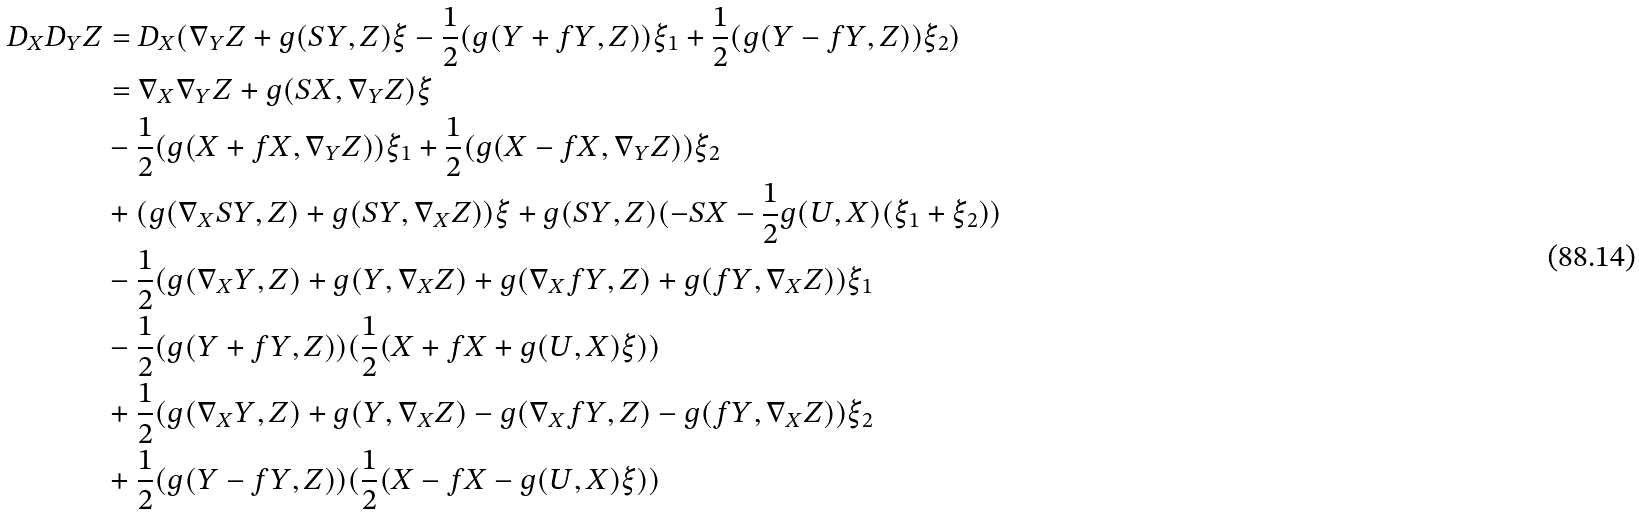Convert formula to latex. <formula><loc_0><loc_0><loc_500><loc_500>D _ { X } D _ { Y } Z & = D _ { X } ( \nabla _ { Y } Z + g ( S Y , Z ) \xi - \frac { 1 } { 2 } ( g ( Y + f Y , Z ) ) \xi _ { 1 } + \frac { 1 } { 2 } ( g ( Y - f Y , Z ) ) \xi _ { 2 } ) \\ & = \nabla _ { X } \nabla _ { Y } Z + g ( S X , \nabla _ { Y } Z ) \xi \\ & - \frac { 1 } { 2 } ( g ( X + f X , \nabla _ { Y } Z ) ) \xi _ { 1 } + \frac { 1 } { 2 } ( g ( X - f X , \nabla _ { Y } Z ) ) \xi _ { 2 } \\ & + ( g ( \nabla _ { X } S Y , Z ) + g ( S Y , \nabla _ { X } Z ) ) \xi + g ( S Y , Z ) ( - S X - \frac { 1 } { 2 } g ( U , X ) ( \xi _ { 1 } + \xi _ { 2 } ) ) \\ & - \frac { 1 } { 2 } ( g ( \nabla _ { X } Y , Z ) + g ( Y , \nabla _ { X } Z ) + g ( \nabla _ { X } f Y , Z ) + g ( f Y , \nabla _ { X } Z ) ) \xi _ { 1 } \\ & - \frac { 1 } { 2 } ( g ( Y + f Y , Z ) ) ( \frac { 1 } { 2 } ( X + f X + g ( U , X ) \xi ) ) \\ & + \frac { 1 } { 2 } ( g ( \nabla _ { X } Y , Z ) + g ( Y , \nabla _ { X } Z ) - g ( \nabla _ { X } f Y , Z ) - g ( f Y , \nabla _ { X } Z ) ) \xi _ { 2 } \\ & + \frac { 1 } { 2 } ( g ( Y - f Y , Z ) ) ( \frac { 1 } { 2 } ( X - f X - g ( U , X ) \xi ) ) \\</formula> 